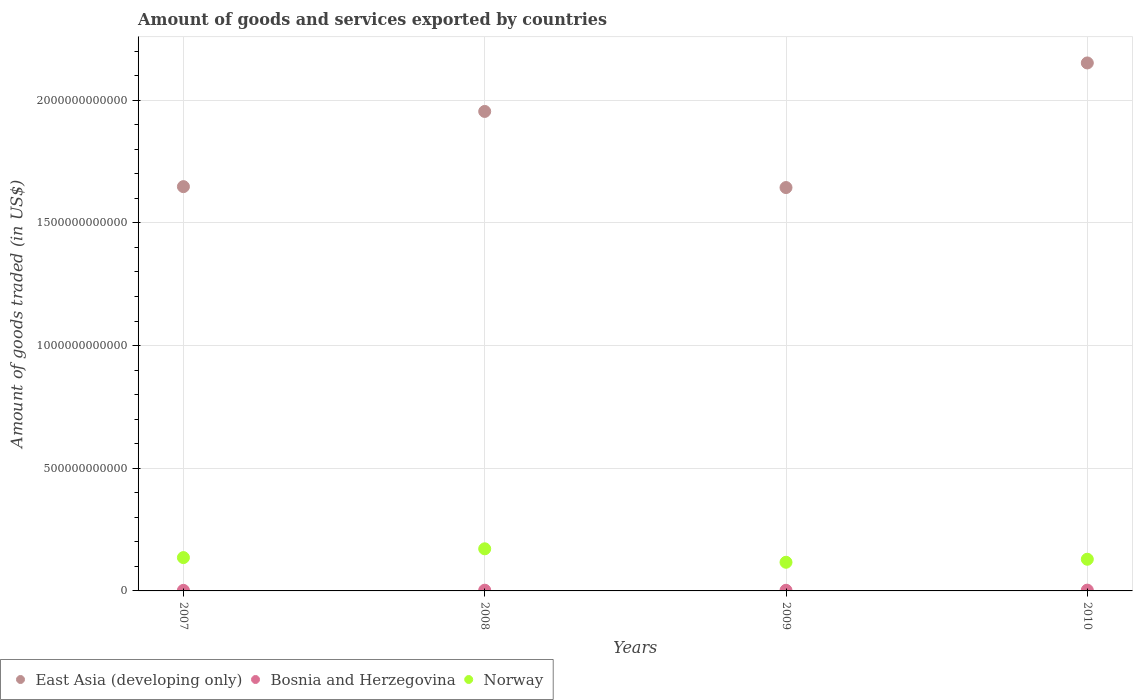Is the number of dotlines equal to the number of legend labels?
Your response must be concise. Yes. What is the total amount of goods and services exported in East Asia (developing only) in 2009?
Offer a terse response. 1.64e+12. Across all years, what is the maximum total amount of goods and services exported in Norway?
Offer a very short reply. 1.72e+11. Across all years, what is the minimum total amount of goods and services exported in East Asia (developing only)?
Make the answer very short. 1.64e+12. In which year was the total amount of goods and services exported in East Asia (developing only) maximum?
Keep it short and to the point. 2010. In which year was the total amount of goods and services exported in Norway minimum?
Offer a very short reply. 2009. What is the total total amount of goods and services exported in Norway in the graph?
Your response must be concise. 5.53e+11. What is the difference between the total amount of goods and services exported in East Asia (developing only) in 2007 and that in 2009?
Your response must be concise. 3.78e+09. What is the difference between the total amount of goods and services exported in Norway in 2010 and the total amount of goods and services exported in Bosnia and Herzegovina in 2008?
Your answer should be compact. 1.26e+11. What is the average total amount of goods and services exported in Bosnia and Herzegovina per year?
Give a very brief answer. 2.75e+09. In the year 2009, what is the difference between the total amount of goods and services exported in Norway and total amount of goods and services exported in Bosnia and Herzegovina?
Offer a terse response. 1.14e+11. In how many years, is the total amount of goods and services exported in East Asia (developing only) greater than 1400000000000 US$?
Your response must be concise. 4. What is the ratio of the total amount of goods and services exported in Bosnia and Herzegovina in 2008 to that in 2009?
Make the answer very short. 1.15. What is the difference between the highest and the second highest total amount of goods and services exported in Bosnia and Herzegovina?
Keep it short and to the point. 3.04e+08. What is the difference between the highest and the lowest total amount of goods and services exported in East Asia (developing only)?
Your answer should be compact. 5.08e+11. Is it the case that in every year, the sum of the total amount of goods and services exported in Bosnia and Herzegovina and total amount of goods and services exported in East Asia (developing only)  is greater than the total amount of goods and services exported in Norway?
Your answer should be compact. Yes. Is the total amount of goods and services exported in East Asia (developing only) strictly greater than the total amount of goods and services exported in Norway over the years?
Provide a short and direct response. Yes. Is the total amount of goods and services exported in Bosnia and Herzegovina strictly less than the total amount of goods and services exported in East Asia (developing only) over the years?
Provide a succinct answer. Yes. How many dotlines are there?
Offer a very short reply. 3. What is the difference between two consecutive major ticks on the Y-axis?
Make the answer very short. 5.00e+11. Are the values on the major ticks of Y-axis written in scientific E-notation?
Make the answer very short. No. Where does the legend appear in the graph?
Your answer should be very brief. Bottom left. How are the legend labels stacked?
Offer a very short reply. Horizontal. What is the title of the graph?
Keep it short and to the point. Amount of goods and services exported by countries. Does "Oman" appear as one of the legend labels in the graph?
Keep it short and to the point. No. What is the label or title of the Y-axis?
Your answer should be compact. Amount of goods traded (in US$). What is the Amount of goods traded (in US$) in East Asia (developing only) in 2007?
Your response must be concise. 1.65e+12. What is the Amount of goods traded (in US$) in Bosnia and Herzegovina in 2007?
Keep it short and to the point. 2.30e+09. What is the Amount of goods traded (in US$) of Norway in 2007?
Offer a terse response. 1.36e+11. What is the Amount of goods traded (in US$) of East Asia (developing only) in 2008?
Your answer should be compact. 1.95e+12. What is the Amount of goods traded (in US$) of Bosnia and Herzegovina in 2008?
Provide a short and direct response. 2.93e+09. What is the Amount of goods traded (in US$) in Norway in 2008?
Provide a short and direct response. 1.72e+11. What is the Amount of goods traded (in US$) in East Asia (developing only) in 2009?
Make the answer very short. 1.64e+12. What is the Amount of goods traded (in US$) of Bosnia and Herzegovina in 2009?
Your answer should be compact. 2.55e+09. What is the Amount of goods traded (in US$) of Norway in 2009?
Offer a very short reply. 1.17e+11. What is the Amount of goods traded (in US$) of East Asia (developing only) in 2010?
Ensure brevity in your answer.  2.15e+12. What is the Amount of goods traded (in US$) in Bosnia and Herzegovina in 2010?
Make the answer very short. 3.23e+09. What is the Amount of goods traded (in US$) in Norway in 2010?
Make the answer very short. 1.29e+11. Across all years, what is the maximum Amount of goods traded (in US$) of East Asia (developing only)?
Make the answer very short. 2.15e+12. Across all years, what is the maximum Amount of goods traded (in US$) in Bosnia and Herzegovina?
Ensure brevity in your answer.  3.23e+09. Across all years, what is the maximum Amount of goods traded (in US$) in Norway?
Your response must be concise. 1.72e+11. Across all years, what is the minimum Amount of goods traded (in US$) in East Asia (developing only)?
Provide a succinct answer. 1.64e+12. Across all years, what is the minimum Amount of goods traded (in US$) of Bosnia and Herzegovina?
Your response must be concise. 2.30e+09. Across all years, what is the minimum Amount of goods traded (in US$) in Norway?
Offer a very short reply. 1.17e+11. What is the total Amount of goods traded (in US$) of East Asia (developing only) in the graph?
Provide a succinct answer. 7.40e+12. What is the total Amount of goods traded (in US$) of Bosnia and Herzegovina in the graph?
Make the answer very short. 1.10e+1. What is the total Amount of goods traded (in US$) of Norway in the graph?
Provide a succinct answer. 5.53e+11. What is the difference between the Amount of goods traded (in US$) of East Asia (developing only) in 2007 and that in 2008?
Ensure brevity in your answer.  -3.07e+11. What is the difference between the Amount of goods traded (in US$) of Bosnia and Herzegovina in 2007 and that in 2008?
Offer a very short reply. -6.28e+08. What is the difference between the Amount of goods traded (in US$) of Norway in 2007 and that in 2008?
Give a very brief answer. -3.58e+1. What is the difference between the Amount of goods traded (in US$) of East Asia (developing only) in 2007 and that in 2009?
Offer a terse response. 3.78e+09. What is the difference between the Amount of goods traded (in US$) of Bosnia and Herzegovina in 2007 and that in 2009?
Give a very brief answer. -2.47e+08. What is the difference between the Amount of goods traded (in US$) of Norway in 2007 and that in 2009?
Your answer should be very brief. 1.90e+1. What is the difference between the Amount of goods traded (in US$) of East Asia (developing only) in 2007 and that in 2010?
Make the answer very short. -5.04e+11. What is the difference between the Amount of goods traded (in US$) in Bosnia and Herzegovina in 2007 and that in 2010?
Your response must be concise. -9.32e+08. What is the difference between the Amount of goods traded (in US$) in Norway in 2007 and that in 2010?
Provide a short and direct response. 6.74e+09. What is the difference between the Amount of goods traded (in US$) of East Asia (developing only) in 2008 and that in 2009?
Offer a very short reply. 3.10e+11. What is the difference between the Amount of goods traded (in US$) of Bosnia and Herzegovina in 2008 and that in 2009?
Make the answer very short. 3.81e+08. What is the difference between the Amount of goods traded (in US$) in Norway in 2008 and that in 2009?
Ensure brevity in your answer.  5.49e+1. What is the difference between the Amount of goods traded (in US$) of East Asia (developing only) in 2008 and that in 2010?
Your answer should be very brief. -1.98e+11. What is the difference between the Amount of goods traded (in US$) of Bosnia and Herzegovina in 2008 and that in 2010?
Offer a very short reply. -3.04e+08. What is the difference between the Amount of goods traded (in US$) of Norway in 2008 and that in 2010?
Provide a succinct answer. 4.26e+1. What is the difference between the Amount of goods traded (in US$) of East Asia (developing only) in 2009 and that in 2010?
Provide a short and direct response. -5.08e+11. What is the difference between the Amount of goods traded (in US$) of Bosnia and Herzegovina in 2009 and that in 2010?
Ensure brevity in your answer.  -6.85e+08. What is the difference between the Amount of goods traded (in US$) in Norway in 2009 and that in 2010?
Ensure brevity in your answer.  -1.23e+1. What is the difference between the Amount of goods traded (in US$) of East Asia (developing only) in 2007 and the Amount of goods traded (in US$) of Bosnia and Herzegovina in 2008?
Your response must be concise. 1.65e+12. What is the difference between the Amount of goods traded (in US$) of East Asia (developing only) in 2007 and the Amount of goods traded (in US$) of Norway in 2008?
Ensure brevity in your answer.  1.48e+12. What is the difference between the Amount of goods traded (in US$) in Bosnia and Herzegovina in 2007 and the Amount of goods traded (in US$) in Norway in 2008?
Provide a short and direct response. -1.69e+11. What is the difference between the Amount of goods traded (in US$) in East Asia (developing only) in 2007 and the Amount of goods traded (in US$) in Bosnia and Herzegovina in 2009?
Offer a terse response. 1.65e+12. What is the difference between the Amount of goods traded (in US$) in East Asia (developing only) in 2007 and the Amount of goods traded (in US$) in Norway in 2009?
Offer a very short reply. 1.53e+12. What is the difference between the Amount of goods traded (in US$) in Bosnia and Herzegovina in 2007 and the Amount of goods traded (in US$) in Norway in 2009?
Your answer should be very brief. -1.15e+11. What is the difference between the Amount of goods traded (in US$) in East Asia (developing only) in 2007 and the Amount of goods traded (in US$) in Bosnia and Herzegovina in 2010?
Your answer should be very brief. 1.64e+12. What is the difference between the Amount of goods traded (in US$) in East Asia (developing only) in 2007 and the Amount of goods traded (in US$) in Norway in 2010?
Ensure brevity in your answer.  1.52e+12. What is the difference between the Amount of goods traded (in US$) of Bosnia and Herzegovina in 2007 and the Amount of goods traded (in US$) of Norway in 2010?
Provide a succinct answer. -1.27e+11. What is the difference between the Amount of goods traded (in US$) of East Asia (developing only) in 2008 and the Amount of goods traded (in US$) of Bosnia and Herzegovina in 2009?
Provide a short and direct response. 1.95e+12. What is the difference between the Amount of goods traded (in US$) in East Asia (developing only) in 2008 and the Amount of goods traded (in US$) in Norway in 2009?
Your response must be concise. 1.84e+12. What is the difference between the Amount of goods traded (in US$) of Bosnia and Herzegovina in 2008 and the Amount of goods traded (in US$) of Norway in 2009?
Offer a terse response. -1.14e+11. What is the difference between the Amount of goods traded (in US$) of East Asia (developing only) in 2008 and the Amount of goods traded (in US$) of Bosnia and Herzegovina in 2010?
Your answer should be compact. 1.95e+12. What is the difference between the Amount of goods traded (in US$) of East Asia (developing only) in 2008 and the Amount of goods traded (in US$) of Norway in 2010?
Give a very brief answer. 1.83e+12. What is the difference between the Amount of goods traded (in US$) in Bosnia and Herzegovina in 2008 and the Amount of goods traded (in US$) in Norway in 2010?
Offer a terse response. -1.26e+11. What is the difference between the Amount of goods traded (in US$) of East Asia (developing only) in 2009 and the Amount of goods traded (in US$) of Bosnia and Herzegovina in 2010?
Offer a terse response. 1.64e+12. What is the difference between the Amount of goods traded (in US$) of East Asia (developing only) in 2009 and the Amount of goods traded (in US$) of Norway in 2010?
Your answer should be very brief. 1.52e+12. What is the difference between the Amount of goods traded (in US$) of Bosnia and Herzegovina in 2009 and the Amount of goods traded (in US$) of Norway in 2010?
Keep it short and to the point. -1.27e+11. What is the average Amount of goods traded (in US$) of East Asia (developing only) per year?
Offer a terse response. 1.85e+12. What is the average Amount of goods traded (in US$) in Bosnia and Herzegovina per year?
Your answer should be very brief. 2.75e+09. What is the average Amount of goods traded (in US$) in Norway per year?
Ensure brevity in your answer.  1.38e+11. In the year 2007, what is the difference between the Amount of goods traded (in US$) in East Asia (developing only) and Amount of goods traded (in US$) in Bosnia and Herzegovina?
Make the answer very short. 1.65e+12. In the year 2007, what is the difference between the Amount of goods traded (in US$) in East Asia (developing only) and Amount of goods traded (in US$) in Norway?
Provide a short and direct response. 1.51e+12. In the year 2007, what is the difference between the Amount of goods traded (in US$) of Bosnia and Herzegovina and Amount of goods traded (in US$) of Norway?
Make the answer very short. -1.34e+11. In the year 2008, what is the difference between the Amount of goods traded (in US$) in East Asia (developing only) and Amount of goods traded (in US$) in Bosnia and Herzegovina?
Offer a very short reply. 1.95e+12. In the year 2008, what is the difference between the Amount of goods traded (in US$) of East Asia (developing only) and Amount of goods traded (in US$) of Norway?
Ensure brevity in your answer.  1.78e+12. In the year 2008, what is the difference between the Amount of goods traded (in US$) of Bosnia and Herzegovina and Amount of goods traded (in US$) of Norway?
Offer a terse response. -1.69e+11. In the year 2009, what is the difference between the Amount of goods traded (in US$) of East Asia (developing only) and Amount of goods traded (in US$) of Bosnia and Herzegovina?
Your answer should be compact. 1.64e+12. In the year 2009, what is the difference between the Amount of goods traded (in US$) in East Asia (developing only) and Amount of goods traded (in US$) in Norway?
Keep it short and to the point. 1.53e+12. In the year 2009, what is the difference between the Amount of goods traded (in US$) in Bosnia and Herzegovina and Amount of goods traded (in US$) in Norway?
Your response must be concise. -1.14e+11. In the year 2010, what is the difference between the Amount of goods traded (in US$) in East Asia (developing only) and Amount of goods traded (in US$) in Bosnia and Herzegovina?
Offer a terse response. 2.15e+12. In the year 2010, what is the difference between the Amount of goods traded (in US$) of East Asia (developing only) and Amount of goods traded (in US$) of Norway?
Ensure brevity in your answer.  2.02e+12. In the year 2010, what is the difference between the Amount of goods traded (in US$) in Bosnia and Herzegovina and Amount of goods traded (in US$) in Norway?
Keep it short and to the point. -1.26e+11. What is the ratio of the Amount of goods traded (in US$) in East Asia (developing only) in 2007 to that in 2008?
Your answer should be compact. 0.84. What is the ratio of the Amount of goods traded (in US$) of Bosnia and Herzegovina in 2007 to that in 2008?
Your answer should be very brief. 0.79. What is the ratio of the Amount of goods traded (in US$) in Norway in 2007 to that in 2008?
Make the answer very short. 0.79. What is the ratio of the Amount of goods traded (in US$) of Bosnia and Herzegovina in 2007 to that in 2009?
Give a very brief answer. 0.9. What is the ratio of the Amount of goods traded (in US$) in Norway in 2007 to that in 2009?
Offer a very short reply. 1.16. What is the ratio of the Amount of goods traded (in US$) in East Asia (developing only) in 2007 to that in 2010?
Give a very brief answer. 0.77. What is the ratio of the Amount of goods traded (in US$) in Bosnia and Herzegovina in 2007 to that in 2010?
Provide a short and direct response. 0.71. What is the ratio of the Amount of goods traded (in US$) of Norway in 2007 to that in 2010?
Make the answer very short. 1.05. What is the ratio of the Amount of goods traded (in US$) of East Asia (developing only) in 2008 to that in 2009?
Ensure brevity in your answer.  1.19. What is the ratio of the Amount of goods traded (in US$) of Bosnia and Herzegovina in 2008 to that in 2009?
Offer a terse response. 1.15. What is the ratio of the Amount of goods traded (in US$) in Norway in 2008 to that in 2009?
Your answer should be very brief. 1.47. What is the ratio of the Amount of goods traded (in US$) in East Asia (developing only) in 2008 to that in 2010?
Keep it short and to the point. 0.91. What is the ratio of the Amount of goods traded (in US$) of Bosnia and Herzegovina in 2008 to that in 2010?
Give a very brief answer. 0.91. What is the ratio of the Amount of goods traded (in US$) of Norway in 2008 to that in 2010?
Your answer should be very brief. 1.33. What is the ratio of the Amount of goods traded (in US$) in East Asia (developing only) in 2009 to that in 2010?
Provide a short and direct response. 0.76. What is the ratio of the Amount of goods traded (in US$) of Bosnia and Herzegovina in 2009 to that in 2010?
Keep it short and to the point. 0.79. What is the ratio of the Amount of goods traded (in US$) in Norway in 2009 to that in 2010?
Keep it short and to the point. 0.9. What is the difference between the highest and the second highest Amount of goods traded (in US$) in East Asia (developing only)?
Your response must be concise. 1.98e+11. What is the difference between the highest and the second highest Amount of goods traded (in US$) of Bosnia and Herzegovina?
Offer a very short reply. 3.04e+08. What is the difference between the highest and the second highest Amount of goods traded (in US$) of Norway?
Ensure brevity in your answer.  3.58e+1. What is the difference between the highest and the lowest Amount of goods traded (in US$) of East Asia (developing only)?
Your answer should be very brief. 5.08e+11. What is the difference between the highest and the lowest Amount of goods traded (in US$) of Bosnia and Herzegovina?
Your answer should be compact. 9.32e+08. What is the difference between the highest and the lowest Amount of goods traded (in US$) of Norway?
Your answer should be compact. 5.49e+1. 